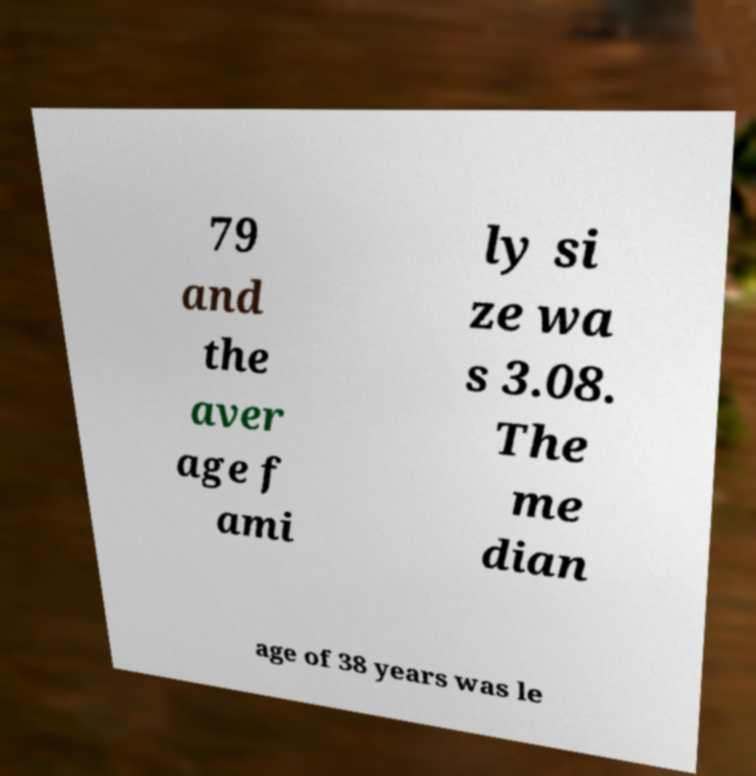I need the written content from this picture converted into text. Can you do that? 79 and the aver age f ami ly si ze wa s 3.08. The me dian age of 38 years was le 